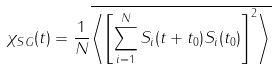Convert formula to latex. <formula><loc_0><loc_0><loc_500><loc_500>\chi _ { S G } ( t ) = \frac { 1 } { N } \overline { \left \langle \left [ \sum _ { i = 1 } ^ { N } S _ { i } ( t + t _ { 0 } ) S _ { i } ( t _ { 0 } ) \right ] ^ { 2 } \right \rangle }</formula> 